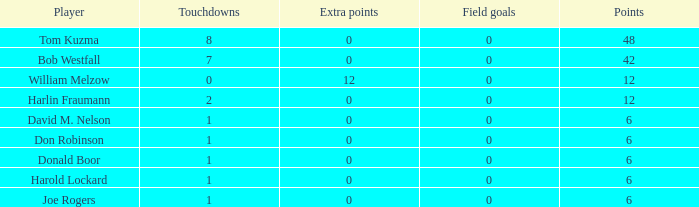Name the least touchdowns for joe rogers 1.0. 